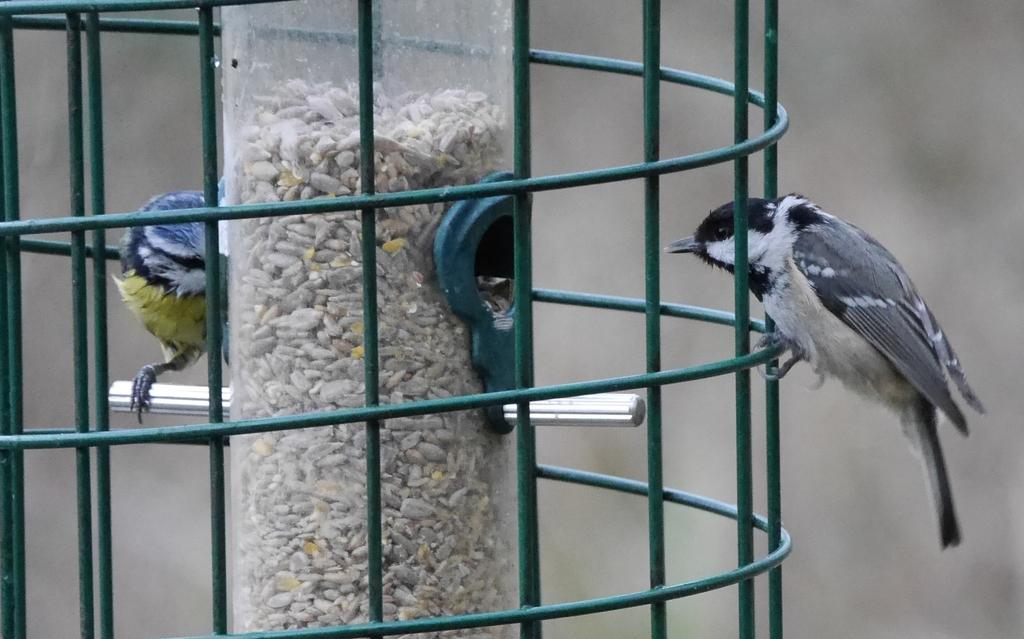What is the main object in the image? There is a cage in the image. What is inside the cage? There are two birds in the cage. Can you describe the background of the image? The background of the image is blurred. What type of writing can be seen on the cage in the image? There is no writing visible on the cage in the image. What material is the brass bird feeder in the image made of? There is no brass bird feeder present in the image. 